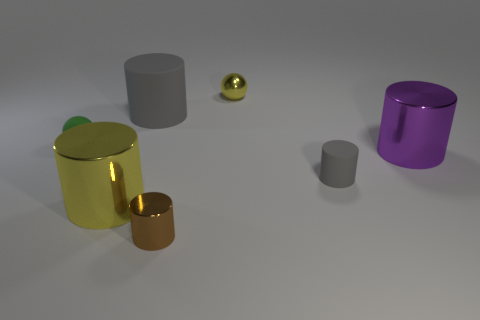What might the context or setting of this image imply? The image seems to be set in a controlled environment, possibly for the purpose of showcasing the objects. The uniform lighting and neutral background suggest a focus on the objects themselves, perhaps for a study of shapes, materials, and reflections. Are these objects indicative of any specific use or function? No specific use or function is apparent from the objects' appearance. They are likely abstract representations used to demonstrate geometric shapes and illustrate how light interacts with different surfaces. 